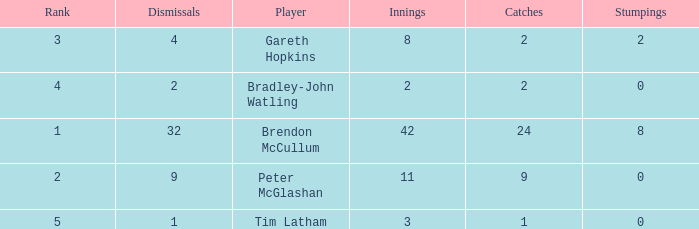List the ranks of all dismissals with a value of 4 3.0. 